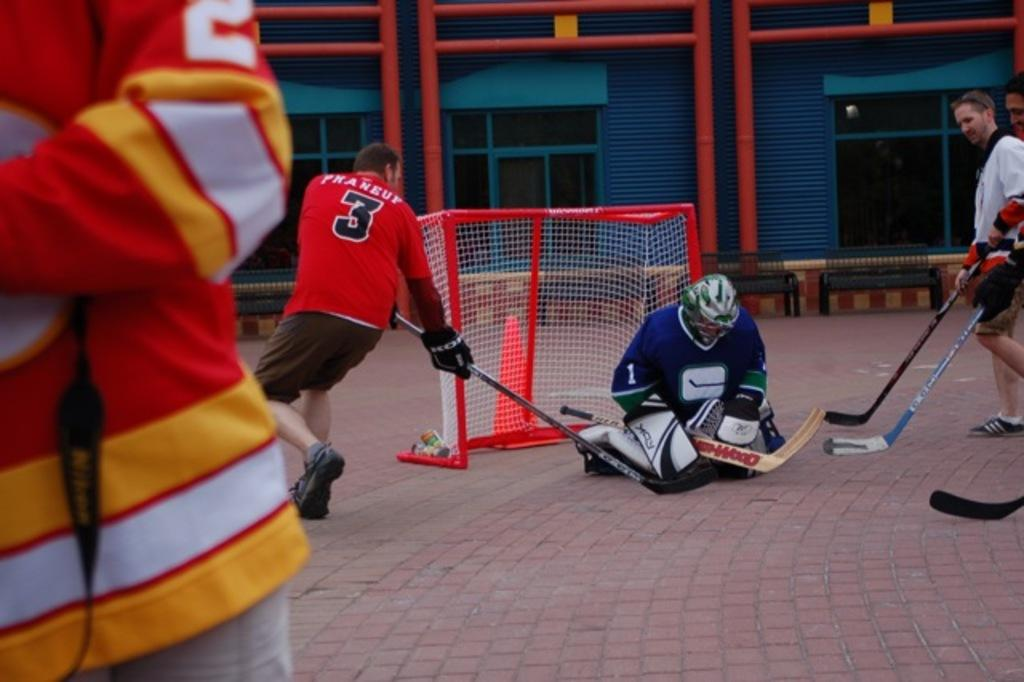<image>
Present a compact description of the photo's key features. the man wearing the red jersey is number 3 